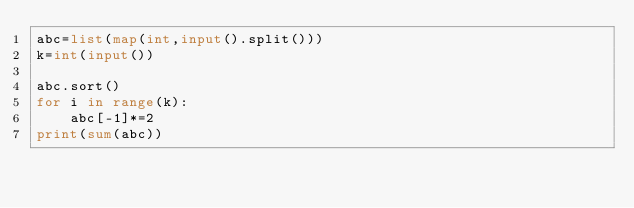Convert code to text. <code><loc_0><loc_0><loc_500><loc_500><_Python_>abc=list(map(int,input().split()))
k=int(input())

abc.sort()
for i in range(k):
    abc[-1]*=2
print(sum(abc))</code> 